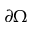<formula> <loc_0><loc_0><loc_500><loc_500>\partial \Omega</formula> 